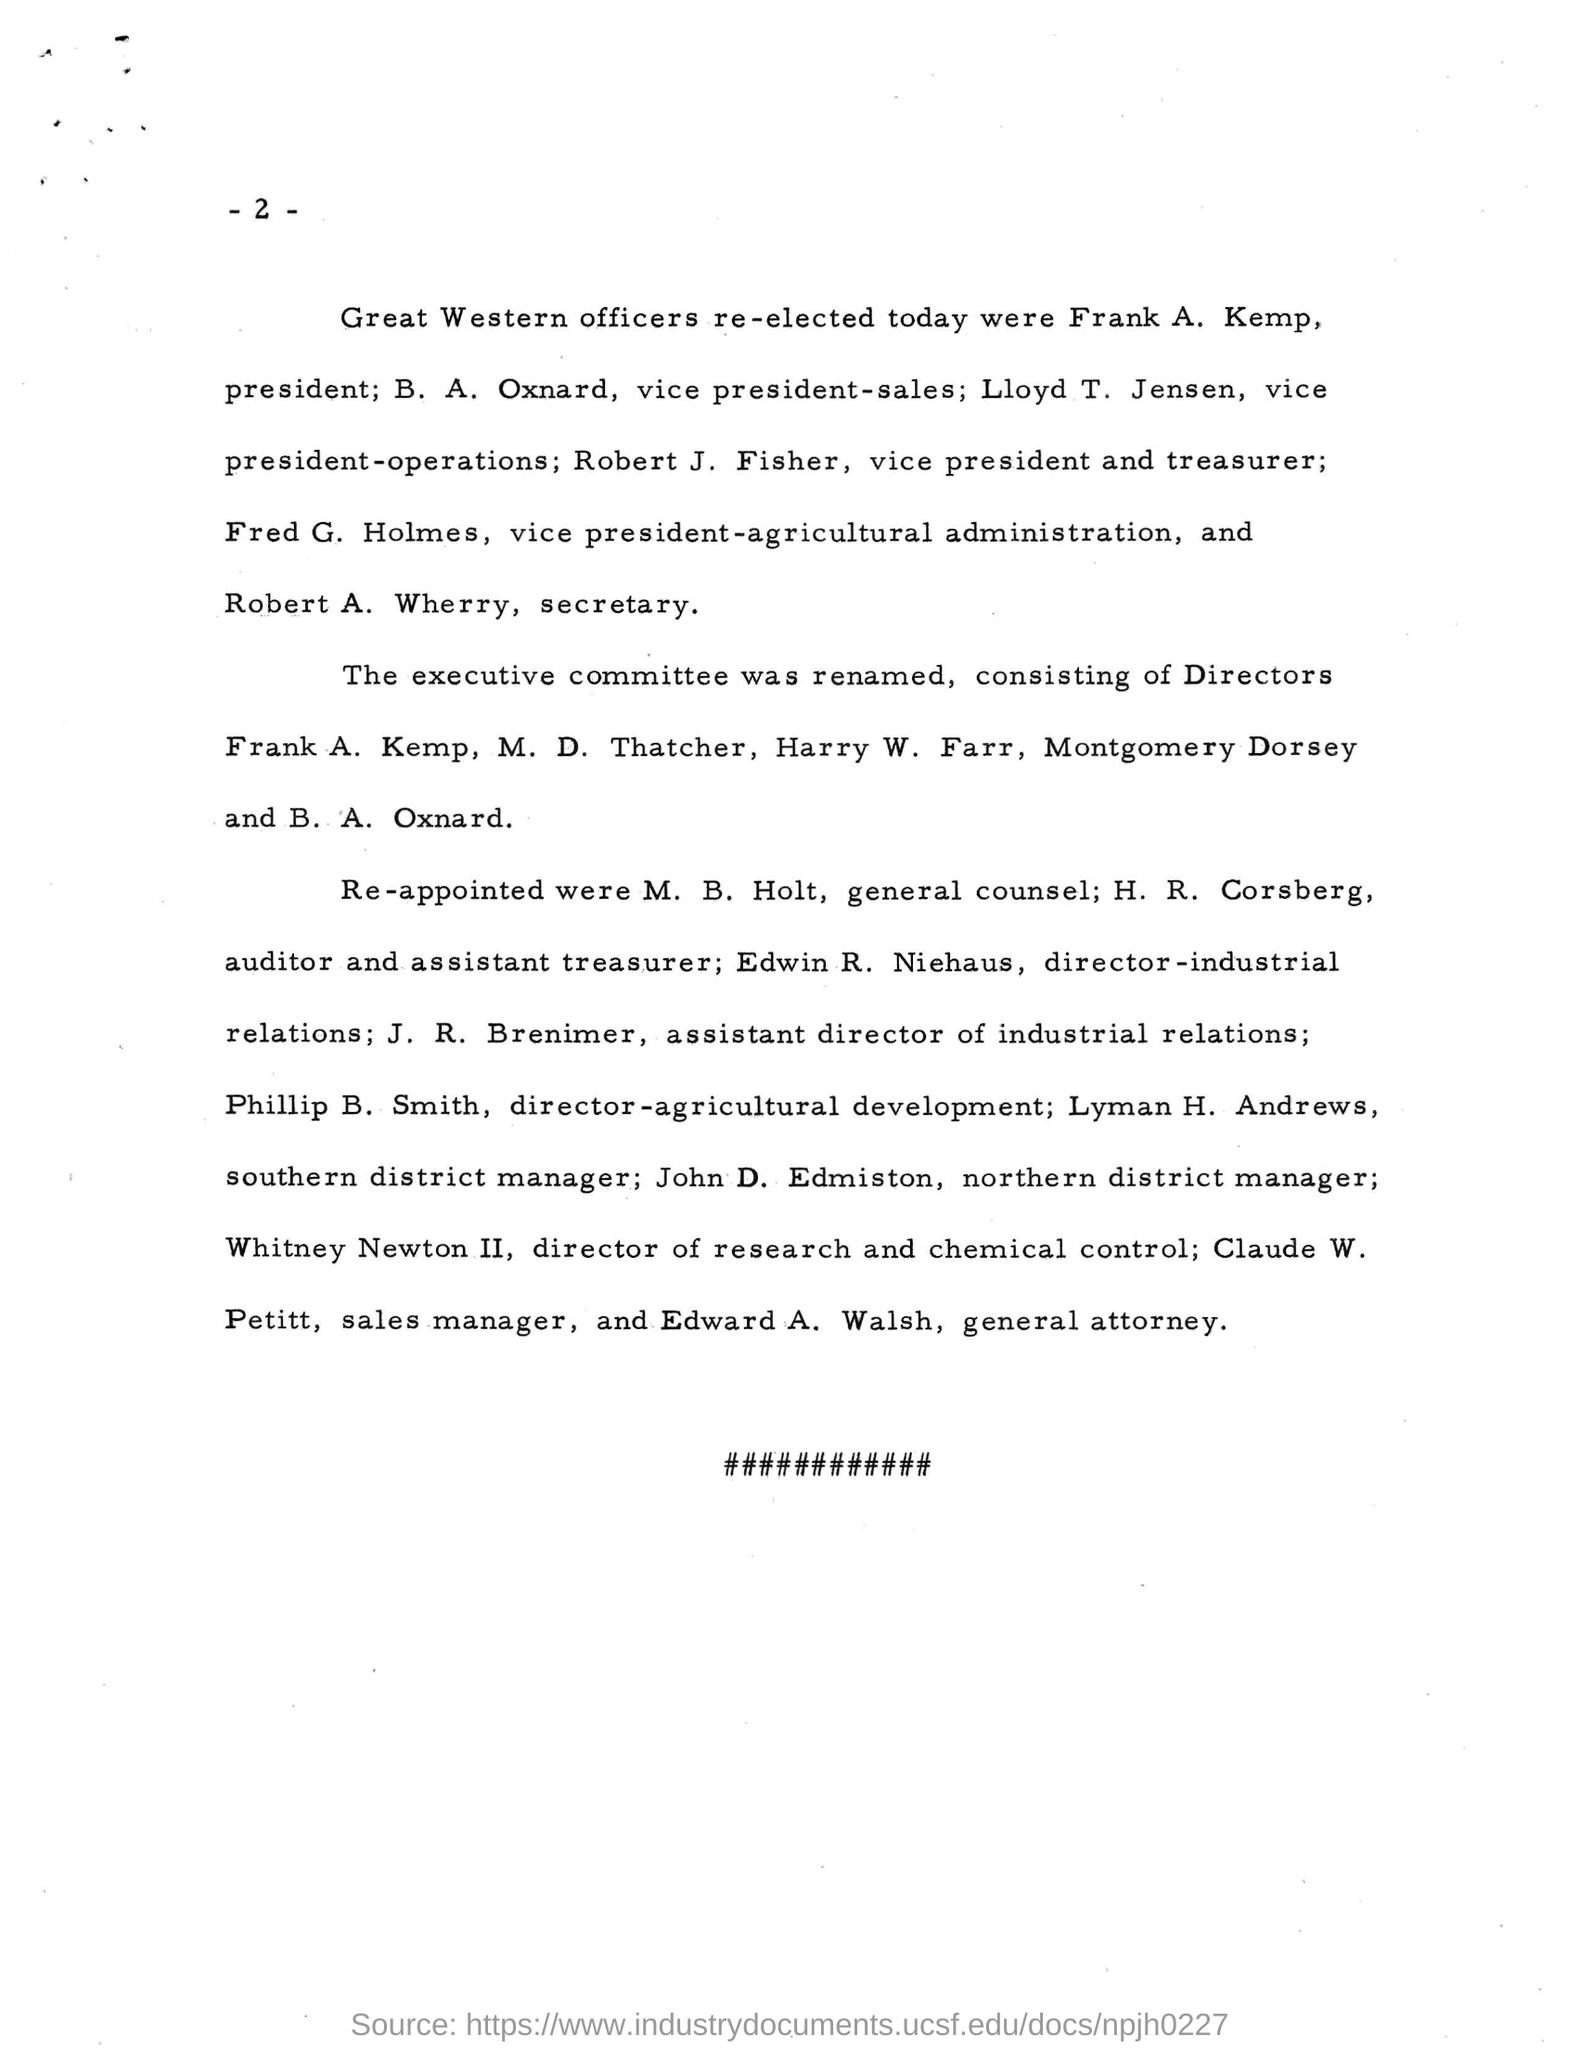Who is the President of Great Western Officers?
Offer a terse response. Frank A. Kemp. Who is the sales manager?
Your answer should be compact. Claude W. Petitt. Who is Edward A. Walsh?
Your response must be concise. The General attorney. 